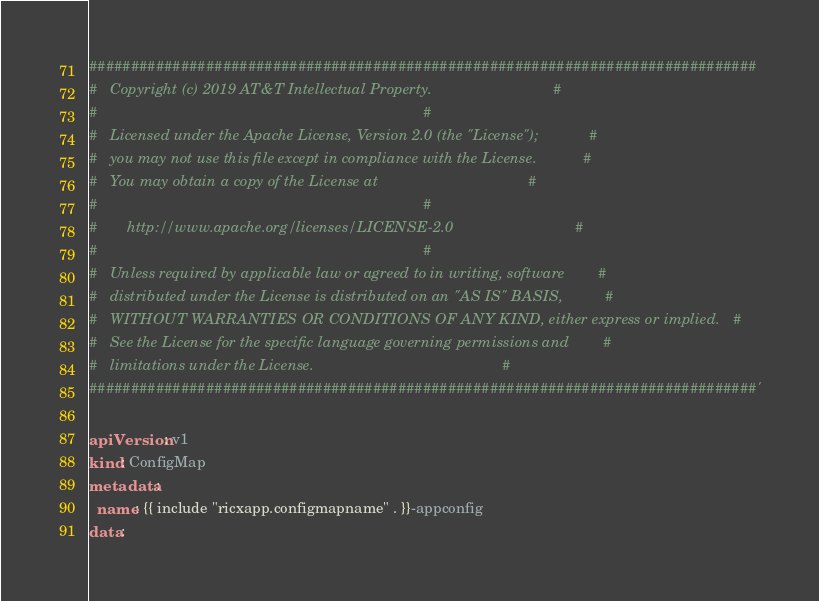<code> <loc_0><loc_0><loc_500><loc_500><_YAML_>################################################################################
#   Copyright (c) 2019 AT&T Intellectual Property.                             #
#                                                                              #
#   Licensed under the Apache License, Version 2.0 (the "License");            #
#   you may not use this file except in compliance with the License.           #
#   You may obtain a copy of the License at                                    #
#                                                                              #
#       http://www.apache.org/licenses/LICENSE-2.0                             #
#                                                                              #
#   Unless required by applicable law or agreed to in writing, software        #
#   distributed under the License is distributed on an "AS IS" BASIS,          #
#   WITHOUT WARRANTIES OR CONDITIONS OF ANY KIND, either express or implied.   #
#   See the License for the specific language governing permissions and        #
#   limitations under the License.                                             #
################################################################################'

apiVersion: v1
kind: ConfigMap
metadata:
  name: {{ include "ricxapp.configmapname" . }}-appconfig
data:
</code> 